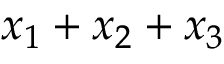Convert formula to latex. <formula><loc_0><loc_0><loc_500><loc_500>x _ { 1 } + x _ { 2 } + x _ { 3 }</formula> 